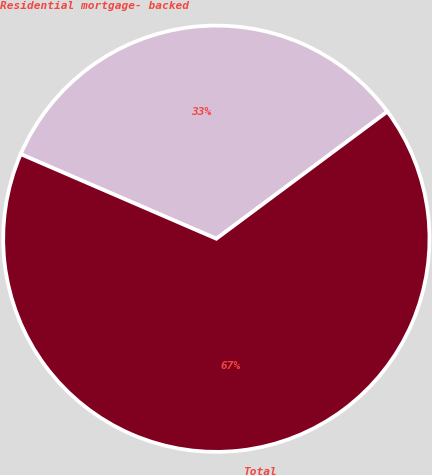Convert chart to OTSL. <chart><loc_0><loc_0><loc_500><loc_500><pie_chart><fcel>Residential mortgage- backed<fcel>Total<nl><fcel>33.33%<fcel>66.67%<nl></chart> 